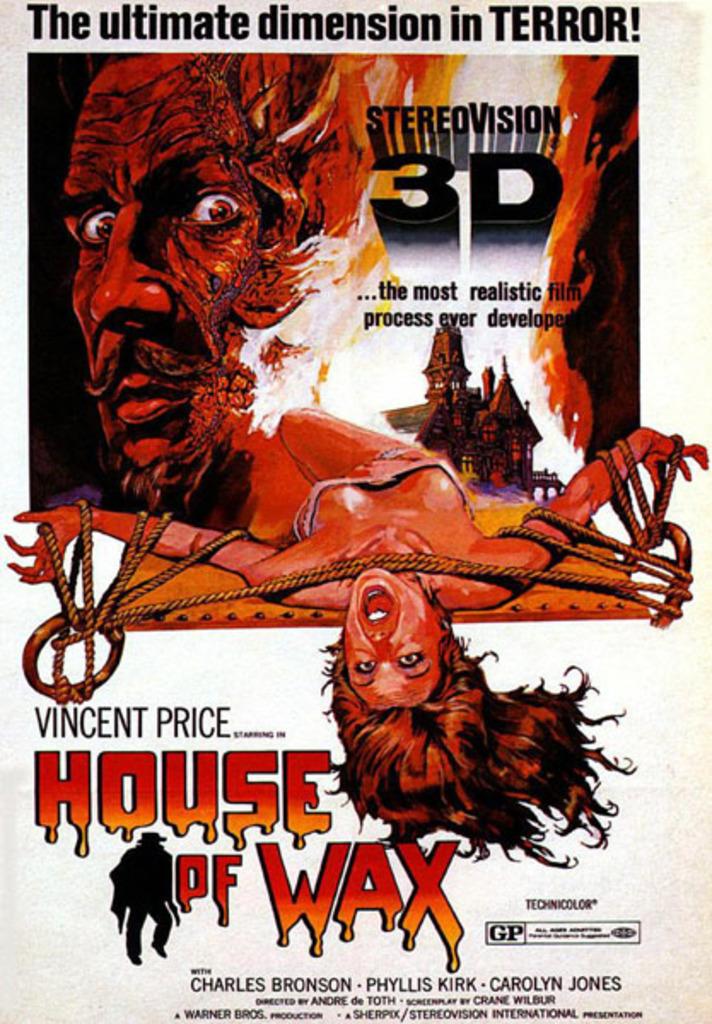What is the title of the game?
Offer a very short reply. House of wax. What is the last name of vincent?
Your answer should be compact. Price. 